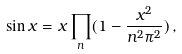<formula> <loc_0><loc_0><loc_500><loc_500>\sin x = x \prod _ { n } ( 1 - \frac { x ^ { 2 } } { n ^ { 2 } \pi ^ { 2 } } ) \, ,</formula> 